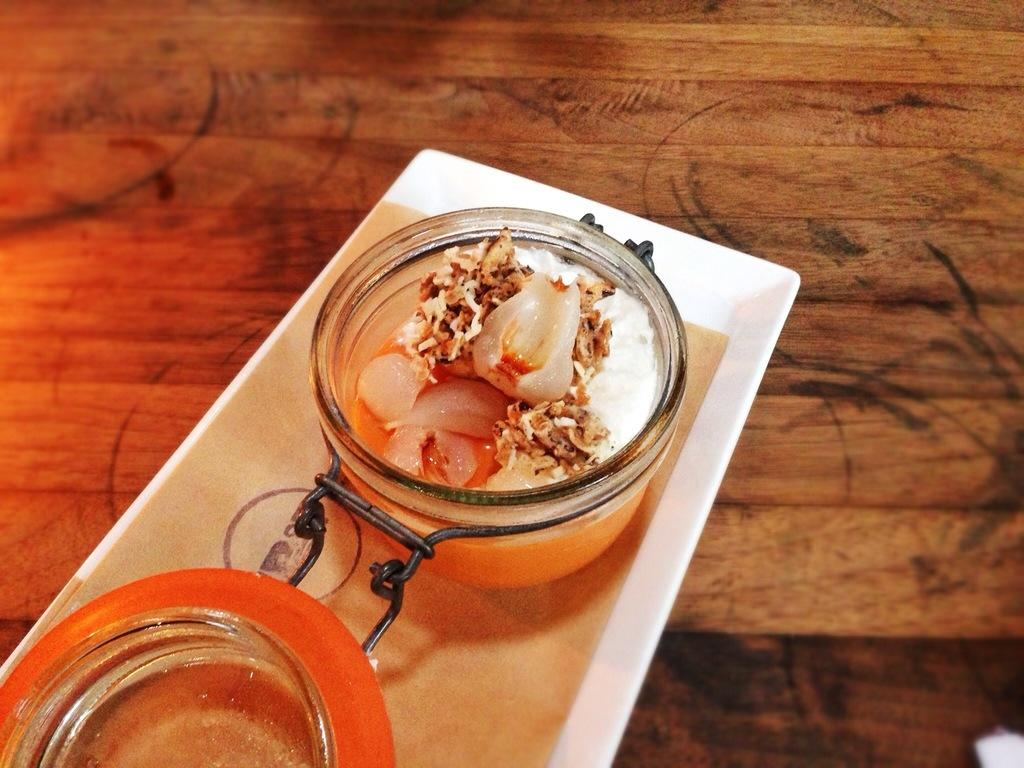What is on the wooden surface in the image? There is a white plate on a wooden surface. What is on the white plate? There is a glass vessel with a food item on the white plate. Can you describe the other dish in the image? There is another bowl on an orange plate. What type of appliance is visible on the front side of the image? There is no appliance visible in the image. What type of rice is being served in the glass vessel? The image does not specify the type of food in the glass vessel, nor does it mention rice. 